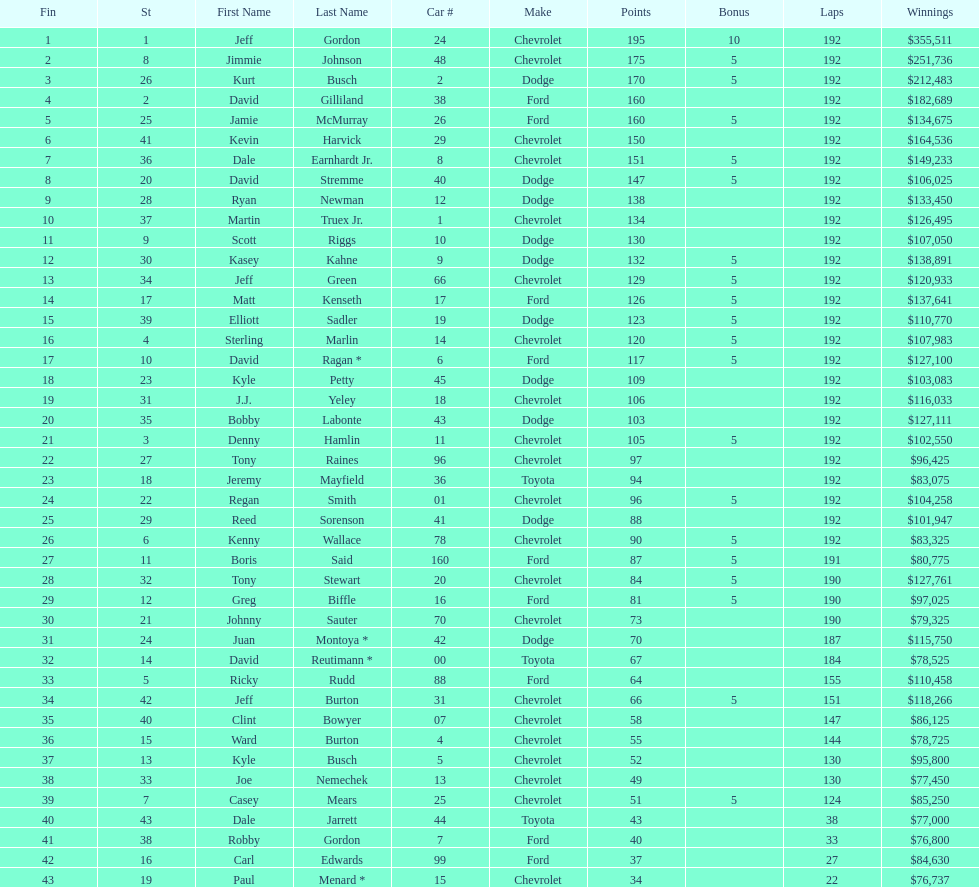How many drivers placed below tony stewart? 15. 